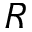Convert formula to latex. <formula><loc_0><loc_0><loc_500><loc_500>R</formula> 